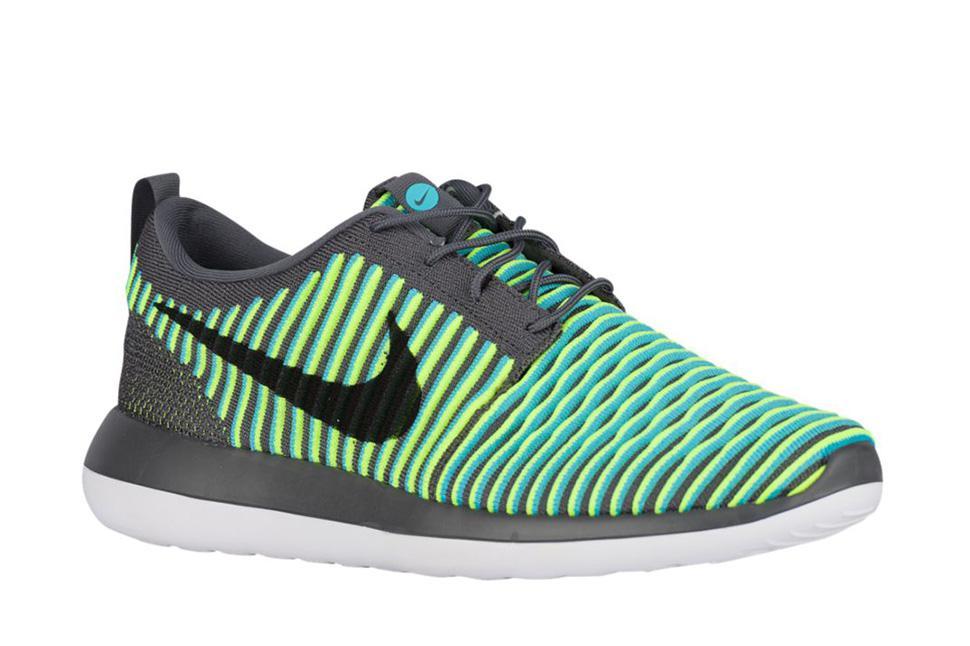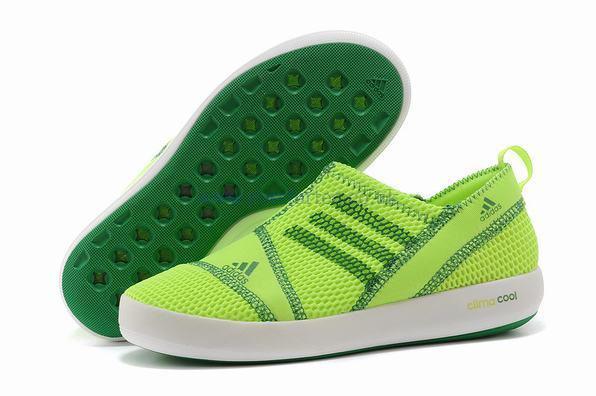The first image is the image on the left, the second image is the image on the right. Considering the images on both sides, is "A pair of shoes, side by side, in one image is a varigated stripe design with a different weave on the heel area and two-toned soles, while a second image shows just one shoe of a similar design, but in a different color." valid? Answer yes or no. No. The first image is the image on the left, the second image is the image on the right. Analyze the images presented: Is the assertion "An image contains at least one green sports shoe." valid? Answer yes or no. Yes. 